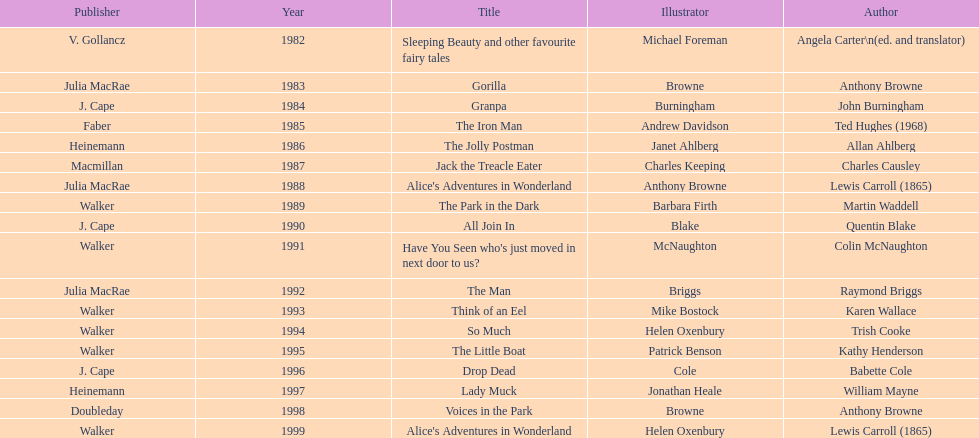Help me parse the entirety of this table. {'header': ['Publisher', 'Year', 'Title', 'Illustrator', 'Author'], 'rows': [['V. Gollancz', '1982', 'Sleeping Beauty and other favourite fairy tales', 'Michael Foreman', 'Angela Carter\\n(ed. and translator)'], ['Julia MacRae', '1983', 'Gorilla', 'Browne', 'Anthony Browne'], ['J. Cape', '1984', 'Granpa', 'Burningham', 'John Burningham'], ['Faber', '1985', 'The Iron Man', 'Andrew Davidson', 'Ted Hughes (1968)'], ['Heinemann', '1986', 'The Jolly Postman', 'Janet Ahlberg', 'Allan Ahlberg'], ['Macmillan', '1987', 'Jack the Treacle Eater', 'Charles Keeping', 'Charles Causley'], ['Julia MacRae', '1988', "Alice's Adventures in Wonderland", 'Anthony Browne', 'Lewis Carroll (1865)'], ['Walker', '1989', 'The Park in the Dark', 'Barbara Firth', 'Martin Waddell'], ['J. Cape', '1990', 'All Join In', 'Blake', 'Quentin Blake'], ['Walker', '1991', "Have You Seen who's just moved in next door to us?", 'McNaughton', 'Colin McNaughton'], ['Julia MacRae', '1992', 'The Man', 'Briggs', 'Raymond Briggs'], ['Walker', '1993', 'Think of an Eel', 'Mike Bostock', 'Karen Wallace'], ['Walker', '1994', 'So Much', 'Helen Oxenbury', 'Trish Cooke'], ['Walker', '1995', 'The Little Boat', 'Patrick Benson', 'Kathy Henderson'], ['J. Cape', '1996', 'Drop Dead', 'Cole', 'Babette Cole'], ['Heinemann', '1997', 'Lady Muck', 'Jonathan Heale', 'William Mayne'], ['Doubleday', '1998', 'Voices in the Park', 'Browne', 'Anthony Browne'], ['Walker', '1999', "Alice's Adventures in Wonderland", 'Helen Oxenbury', 'Lewis Carroll (1865)']]} Which author wrote the first award winner? Angela Carter. 